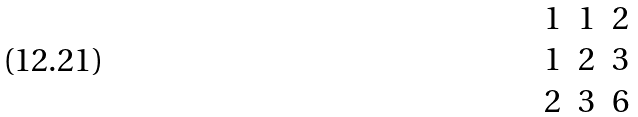Convert formula to latex. <formula><loc_0><loc_0><loc_500><loc_500>\begin{matrix} 1 & 1 & 2 \\ 1 & 2 & 3 \\ 2 & 3 & 6 \\ \end{matrix}</formula> 